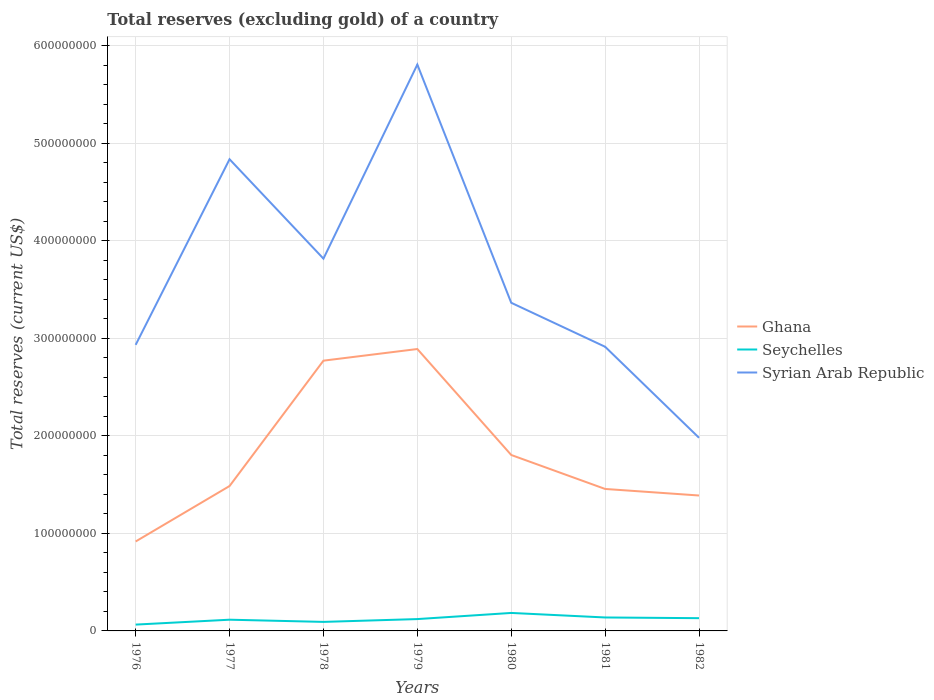Does the line corresponding to Syrian Arab Republic intersect with the line corresponding to Seychelles?
Provide a short and direct response. No. Is the number of lines equal to the number of legend labels?
Ensure brevity in your answer.  Yes. Across all years, what is the maximum total reserves (excluding gold) in Syrian Arab Republic?
Offer a terse response. 1.98e+08. In which year was the total reserves (excluding gold) in Seychelles maximum?
Make the answer very short. 1976. What is the total total reserves (excluding gold) in Ghana in the graph?
Ensure brevity in your answer.  -8.87e+07. What is the difference between the highest and the second highest total reserves (excluding gold) in Syrian Arab Republic?
Your answer should be very brief. 3.83e+08. What is the difference between the highest and the lowest total reserves (excluding gold) in Syrian Arab Republic?
Provide a short and direct response. 3. Is the total reserves (excluding gold) in Syrian Arab Republic strictly greater than the total reserves (excluding gold) in Seychelles over the years?
Provide a succinct answer. No. How many lines are there?
Your answer should be compact. 3. How many years are there in the graph?
Your answer should be very brief. 7. What is the difference between two consecutive major ticks on the Y-axis?
Give a very brief answer. 1.00e+08. Are the values on the major ticks of Y-axis written in scientific E-notation?
Make the answer very short. No. How are the legend labels stacked?
Offer a terse response. Vertical. What is the title of the graph?
Give a very brief answer. Total reserves (excluding gold) of a country. Does "Paraguay" appear as one of the legend labels in the graph?
Ensure brevity in your answer.  No. What is the label or title of the Y-axis?
Make the answer very short. Total reserves (current US$). What is the Total reserves (current US$) in Ghana in 1976?
Ensure brevity in your answer.  9.17e+07. What is the Total reserves (current US$) of Seychelles in 1976?
Your response must be concise. 6.49e+06. What is the Total reserves (current US$) of Syrian Arab Republic in 1976?
Your answer should be compact. 2.93e+08. What is the Total reserves (current US$) of Ghana in 1977?
Keep it short and to the point. 1.49e+08. What is the Total reserves (current US$) of Seychelles in 1977?
Keep it short and to the point. 1.15e+07. What is the Total reserves (current US$) of Syrian Arab Republic in 1977?
Keep it short and to the point. 4.84e+08. What is the Total reserves (current US$) of Ghana in 1978?
Provide a short and direct response. 2.77e+08. What is the Total reserves (current US$) in Seychelles in 1978?
Ensure brevity in your answer.  9.26e+06. What is the Total reserves (current US$) of Syrian Arab Republic in 1978?
Your answer should be very brief. 3.82e+08. What is the Total reserves (current US$) in Ghana in 1979?
Keep it short and to the point. 2.89e+08. What is the Total reserves (current US$) in Seychelles in 1979?
Provide a succinct answer. 1.21e+07. What is the Total reserves (current US$) of Syrian Arab Republic in 1979?
Ensure brevity in your answer.  5.81e+08. What is the Total reserves (current US$) in Ghana in 1980?
Provide a short and direct response. 1.80e+08. What is the Total reserves (current US$) in Seychelles in 1980?
Offer a very short reply. 1.84e+07. What is the Total reserves (current US$) of Syrian Arab Republic in 1980?
Make the answer very short. 3.37e+08. What is the Total reserves (current US$) of Ghana in 1981?
Your answer should be compact. 1.46e+08. What is the Total reserves (current US$) in Seychelles in 1981?
Give a very brief answer. 1.38e+07. What is the Total reserves (current US$) of Syrian Arab Republic in 1981?
Your response must be concise. 2.91e+08. What is the Total reserves (current US$) in Ghana in 1982?
Make the answer very short. 1.39e+08. What is the Total reserves (current US$) of Seychelles in 1982?
Your response must be concise. 1.31e+07. What is the Total reserves (current US$) of Syrian Arab Republic in 1982?
Your answer should be compact. 1.98e+08. Across all years, what is the maximum Total reserves (current US$) of Ghana?
Give a very brief answer. 2.89e+08. Across all years, what is the maximum Total reserves (current US$) in Seychelles?
Make the answer very short. 1.84e+07. Across all years, what is the maximum Total reserves (current US$) of Syrian Arab Republic?
Give a very brief answer. 5.81e+08. Across all years, what is the minimum Total reserves (current US$) in Ghana?
Offer a very short reply. 9.17e+07. Across all years, what is the minimum Total reserves (current US$) of Seychelles?
Keep it short and to the point. 6.49e+06. Across all years, what is the minimum Total reserves (current US$) in Syrian Arab Republic?
Make the answer very short. 1.98e+08. What is the total Total reserves (current US$) of Ghana in the graph?
Offer a terse response. 1.27e+09. What is the total Total reserves (current US$) of Seychelles in the graph?
Offer a very short reply. 8.47e+07. What is the total Total reserves (current US$) of Syrian Arab Republic in the graph?
Give a very brief answer. 2.57e+09. What is the difference between the Total reserves (current US$) of Ghana in 1976 and that in 1977?
Your response must be concise. -5.69e+07. What is the difference between the Total reserves (current US$) of Seychelles in 1976 and that in 1977?
Your answer should be compact. -5.02e+06. What is the difference between the Total reserves (current US$) in Syrian Arab Republic in 1976 and that in 1977?
Keep it short and to the point. -1.90e+08. What is the difference between the Total reserves (current US$) of Ghana in 1976 and that in 1978?
Your answer should be compact. -1.85e+08. What is the difference between the Total reserves (current US$) in Seychelles in 1976 and that in 1978?
Give a very brief answer. -2.77e+06. What is the difference between the Total reserves (current US$) of Syrian Arab Republic in 1976 and that in 1978?
Your answer should be very brief. -8.84e+07. What is the difference between the Total reserves (current US$) of Ghana in 1976 and that in 1979?
Give a very brief answer. -1.97e+08. What is the difference between the Total reserves (current US$) of Seychelles in 1976 and that in 1979?
Your answer should be very brief. -5.66e+06. What is the difference between the Total reserves (current US$) of Syrian Arab Republic in 1976 and that in 1979?
Offer a terse response. -2.87e+08. What is the difference between the Total reserves (current US$) in Ghana in 1976 and that in 1980?
Your answer should be compact. -8.87e+07. What is the difference between the Total reserves (current US$) in Seychelles in 1976 and that in 1980?
Give a very brief answer. -1.19e+07. What is the difference between the Total reserves (current US$) of Syrian Arab Republic in 1976 and that in 1980?
Offer a very short reply. -4.31e+07. What is the difference between the Total reserves (current US$) of Ghana in 1976 and that in 1981?
Provide a short and direct response. -5.39e+07. What is the difference between the Total reserves (current US$) in Seychelles in 1976 and that in 1981?
Your response must be concise. -7.31e+06. What is the difference between the Total reserves (current US$) of Syrian Arab Republic in 1976 and that in 1981?
Provide a succinct answer. 1.97e+06. What is the difference between the Total reserves (current US$) in Ghana in 1976 and that in 1982?
Provide a succinct answer. -4.71e+07. What is the difference between the Total reserves (current US$) of Seychelles in 1976 and that in 1982?
Provide a short and direct response. -6.58e+06. What is the difference between the Total reserves (current US$) of Syrian Arab Republic in 1976 and that in 1982?
Offer a very short reply. 9.53e+07. What is the difference between the Total reserves (current US$) in Ghana in 1977 and that in 1978?
Keep it short and to the point. -1.29e+08. What is the difference between the Total reserves (current US$) in Seychelles in 1977 and that in 1978?
Your answer should be very brief. 2.25e+06. What is the difference between the Total reserves (current US$) in Syrian Arab Republic in 1977 and that in 1978?
Ensure brevity in your answer.  1.02e+08. What is the difference between the Total reserves (current US$) of Ghana in 1977 and that in 1979?
Provide a succinct answer. -1.41e+08. What is the difference between the Total reserves (current US$) of Seychelles in 1977 and that in 1979?
Your answer should be very brief. -6.36e+05. What is the difference between the Total reserves (current US$) in Syrian Arab Republic in 1977 and that in 1979?
Provide a short and direct response. -9.71e+07. What is the difference between the Total reserves (current US$) of Ghana in 1977 and that in 1980?
Ensure brevity in your answer.  -3.18e+07. What is the difference between the Total reserves (current US$) in Seychelles in 1977 and that in 1980?
Give a very brief answer. -6.93e+06. What is the difference between the Total reserves (current US$) in Syrian Arab Republic in 1977 and that in 1980?
Provide a short and direct response. 1.47e+08. What is the difference between the Total reserves (current US$) of Ghana in 1977 and that in 1981?
Your answer should be very brief. 2.99e+06. What is the difference between the Total reserves (current US$) of Seychelles in 1977 and that in 1981?
Offer a very short reply. -2.29e+06. What is the difference between the Total reserves (current US$) in Syrian Arab Republic in 1977 and that in 1981?
Give a very brief answer. 1.92e+08. What is the difference between the Total reserves (current US$) of Ghana in 1977 and that in 1982?
Offer a very short reply. 9.71e+06. What is the difference between the Total reserves (current US$) in Seychelles in 1977 and that in 1982?
Offer a very short reply. -1.56e+06. What is the difference between the Total reserves (current US$) in Syrian Arab Republic in 1977 and that in 1982?
Provide a succinct answer. 2.86e+08. What is the difference between the Total reserves (current US$) in Ghana in 1978 and that in 1979?
Your response must be concise. -1.19e+07. What is the difference between the Total reserves (current US$) in Seychelles in 1978 and that in 1979?
Your answer should be compact. -2.89e+06. What is the difference between the Total reserves (current US$) of Syrian Arab Republic in 1978 and that in 1979?
Provide a short and direct response. -1.99e+08. What is the difference between the Total reserves (current US$) in Ghana in 1978 and that in 1980?
Offer a terse response. 9.67e+07. What is the difference between the Total reserves (current US$) of Seychelles in 1978 and that in 1980?
Offer a terse response. -9.18e+06. What is the difference between the Total reserves (current US$) in Syrian Arab Republic in 1978 and that in 1980?
Your answer should be compact. 4.53e+07. What is the difference between the Total reserves (current US$) of Ghana in 1978 and that in 1981?
Offer a terse response. 1.32e+08. What is the difference between the Total reserves (current US$) in Seychelles in 1978 and that in 1981?
Give a very brief answer. -4.54e+06. What is the difference between the Total reserves (current US$) in Syrian Arab Republic in 1978 and that in 1981?
Offer a terse response. 9.04e+07. What is the difference between the Total reserves (current US$) in Ghana in 1978 and that in 1982?
Your answer should be very brief. 1.38e+08. What is the difference between the Total reserves (current US$) in Seychelles in 1978 and that in 1982?
Your answer should be compact. -3.81e+06. What is the difference between the Total reserves (current US$) in Syrian Arab Republic in 1978 and that in 1982?
Provide a short and direct response. 1.84e+08. What is the difference between the Total reserves (current US$) in Ghana in 1979 and that in 1980?
Offer a very short reply. 1.09e+08. What is the difference between the Total reserves (current US$) of Seychelles in 1979 and that in 1980?
Provide a short and direct response. -6.29e+06. What is the difference between the Total reserves (current US$) in Syrian Arab Republic in 1979 and that in 1980?
Your response must be concise. 2.44e+08. What is the difference between the Total reserves (current US$) of Ghana in 1979 and that in 1981?
Your response must be concise. 1.44e+08. What is the difference between the Total reserves (current US$) of Seychelles in 1979 and that in 1981?
Give a very brief answer. -1.65e+06. What is the difference between the Total reserves (current US$) in Syrian Arab Republic in 1979 and that in 1981?
Your answer should be compact. 2.89e+08. What is the difference between the Total reserves (current US$) of Ghana in 1979 and that in 1982?
Offer a terse response. 1.50e+08. What is the difference between the Total reserves (current US$) of Seychelles in 1979 and that in 1982?
Your answer should be very brief. -9.24e+05. What is the difference between the Total reserves (current US$) of Syrian Arab Republic in 1979 and that in 1982?
Provide a succinct answer. 3.83e+08. What is the difference between the Total reserves (current US$) in Ghana in 1980 and that in 1981?
Give a very brief answer. 3.48e+07. What is the difference between the Total reserves (current US$) of Seychelles in 1980 and that in 1981?
Make the answer very short. 4.64e+06. What is the difference between the Total reserves (current US$) of Syrian Arab Republic in 1980 and that in 1981?
Provide a succinct answer. 4.51e+07. What is the difference between the Total reserves (current US$) in Ghana in 1980 and that in 1982?
Keep it short and to the point. 4.16e+07. What is the difference between the Total reserves (current US$) in Seychelles in 1980 and that in 1982?
Give a very brief answer. 5.37e+06. What is the difference between the Total reserves (current US$) in Syrian Arab Republic in 1980 and that in 1982?
Your answer should be compact. 1.38e+08. What is the difference between the Total reserves (current US$) of Ghana in 1981 and that in 1982?
Offer a terse response. 6.71e+06. What is the difference between the Total reserves (current US$) in Seychelles in 1981 and that in 1982?
Ensure brevity in your answer.  7.28e+05. What is the difference between the Total reserves (current US$) in Syrian Arab Republic in 1981 and that in 1982?
Your answer should be very brief. 9.33e+07. What is the difference between the Total reserves (current US$) in Ghana in 1976 and the Total reserves (current US$) in Seychelles in 1977?
Your response must be concise. 8.02e+07. What is the difference between the Total reserves (current US$) of Ghana in 1976 and the Total reserves (current US$) of Syrian Arab Republic in 1977?
Your answer should be very brief. -3.92e+08. What is the difference between the Total reserves (current US$) of Seychelles in 1976 and the Total reserves (current US$) of Syrian Arab Republic in 1977?
Your answer should be very brief. -4.77e+08. What is the difference between the Total reserves (current US$) of Ghana in 1976 and the Total reserves (current US$) of Seychelles in 1978?
Provide a short and direct response. 8.25e+07. What is the difference between the Total reserves (current US$) of Ghana in 1976 and the Total reserves (current US$) of Syrian Arab Republic in 1978?
Keep it short and to the point. -2.90e+08. What is the difference between the Total reserves (current US$) of Seychelles in 1976 and the Total reserves (current US$) of Syrian Arab Republic in 1978?
Your response must be concise. -3.75e+08. What is the difference between the Total reserves (current US$) of Ghana in 1976 and the Total reserves (current US$) of Seychelles in 1979?
Your answer should be compact. 7.96e+07. What is the difference between the Total reserves (current US$) in Ghana in 1976 and the Total reserves (current US$) in Syrian Arab Republic in 1979?
Keep it short and to the point. -4.89e+08. What is the difference between the Total reserves (current US$) in Seychelles in 1976 and the Total reserves (current US$) in Syrian Arab Republic in 1979?
Provide a succinct answer. -5.74e+08. What is the difference between the Total reserves (current US$) in Ghana in 1976 and the Total reserves (current US$) in Seychelles in 1980?
Your response must be concise. 7.33e+07. What is the difference between the Total reserves (current US$) of Ghana in 1976 and the Total reserves (current US$) of Syrian Arab Republic in 1980?
Your response must be concise. -2.45e+08. What is the difference between the Total reserves (current US$) of Seychelles in 1976 and the Total reserves (current US$) of Syrian Arab Republic in 1980?
Give a very brief answer. -3.30e+08. What is the difference between the Total reserves (current US$) of Ghana in 1976 and the Total reserves (current US$) of Seychelles in 1981?
Your answer should be compact. 7.79e+07. What is the difference between the Total reserves (current US$) in Ghana in 1976 and the Total reserves (current US$) in Syrian Arab Republic in 1981?
Provide a succinct answer. -2.00e+08. What is the difference between the Total reserves (current US$) of Seychelles in 1976 and the Total reserves (current US$) of Syrian Arab Republic in 1981?
Make the answer very short. -2.85e+08. What is the difference between the Total reserves (current US$) in Ghana in 1976 and the Total reserves (current US$) in Seychelles in 1982?
Make the answer very short. 7.87e+07. What is the difference between the Total reserves (current US$) in Ghana in 1976 and the Total reserves (current US$) in Syrian Arab Republic in 1982?
Provide a short and direct response. -1.06e+08. What is the difference between the Total reserves (current US$) of Seychelles in 1976 and the Total reserves (current US$) of Syrian Arab Republic in 1982?
Your answer should be compact. -1.92e+08. What is the difference between the Total reserves (current US$) of Ghana in 1977 and the Total reserves (current US$) of Seychelles in 1978?
Your answer should be very brief. 1.39e+08. What is the difference between the Total reserves (current US$) of Ghana in 1977 and the Total reserves (current US$) of Syrian Arab Republic in 1978?
Give a very brief answer. -2.33e+08. What is the difference between the Total reserves (current US$) of Seychelles in 1977 and the Total reserves (current US$) of Syrian Arab Republic in 1978?
Offer a very short reply. -3.70e+08. What is the difference between the Total reserves (current US$) in Ghana in 1977 and the Total reserves (current US$) in Seychelles in 1979?
Provide a short and direct response. 1.36e+08. What is the difference between the Total reserves (current US$) in Ghana in 1977 and the Total reserves (current US$) in Syrian Arab Republic in 1979?
Your answer should be compact. -4.32e+08. What is the difference between the Total reserves (current US$) in Seychelles in 1977 and the Total reserves (current US$) in Syrian Arab Republic in 1979?
Keep it short and to the point. -5.69e+08. What is the difference between the Total reserves (current US$) of Ghana in 1977 and the Total reserves (current US$) of Seychelles in 1980?
Your answer should be very brief. 1.30e+08. What is the difference between the Total reserves (current US$) in Ghana in 1977 and the Total reserves (current US$) in Syrian Arab Republic in 1980?
Keep it short and to the point. -1.88e+08. What is the difference between the Total reserves (current US$) in Seychelles in 1977 and the Total reserves (current US$) in Syrian Arab Republic in 1980?
Give a very brief answer. -3.25e+08. What is the difference between the Total reserves (current US$) of Ghana in 1977 and the Total reserves (current US$) of Seychelles in 1981?
Offer a terse response. 1.35e+08. What is the difference between the Total reserves (current US$) in Ghana in 1977 and the Total reserves (current US$) in Syrian Arab Republic in 1981?
Keep it short and to the point. -1.43e+08. What is the difference between the Total reserves (current US$) in Seychelles in 1977 and the Total reserves (current US$) in Syrian Arab Republic in 1981?
Give a very brief answer. -2.80e+08. What is the difference between the Total reserves (current US$) in Ghana in 1977 and the Total reserves (current US$) in Seychelles in 1982?
Your answer should be very brief. 1.36e+08. What is the difference between the Total reserves (current US$) in Ghana in 1977 and the Total reserves (current US$) in Syrian Arab Republic in 1982?
Provide a succinct answer. -4.95e+07. What is the difference between the Total reserves (current US$) in Seychelles in 1977 and the Total reserves (current US$) in Syrian Arab Republic in 1982?
Make the answer very short. -1.87e+08. What is the difference between the Total reserves (current US$) of Ghana in 1978 and the Total reserves (current US$) of Seychelles in 1979?
Keep it short and to the point. 2.65e+08. What is the difference between the Total reserves (current US$) of Ghana in 1978 and the Total reserves (current US$) of Syrian Arab Republic in 1979?
Provide a short and direct response. -3.04e+08. What is the difference between the Total reserves (current US$) of Seychelles in 1978 and the Total reserves (current US$) of Syrian Arab Republic in 1979?
Provide a succinct answer. -5.72e+08. What is the difference between the Total reserves (current US$) in Ghana in 1978 and the Total reserves (current US$) in Seychelles in 1980?
Your response must be concise. 2.59e+08. What is the difference between the Total reserves (current US$) in Ghana in 1978 and the Total reserves (current US$) in Syrian Arab Republic in 1980?
Make the answer very short. -5.94e+07. What is the difference between the Total reserves (current US$) in Seychelles in 1978 and the Total reserves (current US$) in Syrian Arab Republic in 1980?
Your response must be concise. -3.27e+08. What is the difference between the Total reserves (current US$) in Ghana in 1978 and the Total reserves (current US$) in Seychelles in 1981?
Keep it short and to the point. 2.63e+08. What is the difference between the Total reserves (current US$) of Ghana in 1978 and the Total reserves (current US$) of Syrian Arab Republic in 1981?
Your answer should be compact. -1.43e+07. What is the difference between the Total reserves (current US$) in Seychelles in 1978 and the Total reserves (current US$) in Syrian Arab Republic in 1981?
Keep it short and to the point. -2.82e+08. What is the difference between the Total reserves (current US$) in Ghana in 1978 and the Total reserves (current US$) in Seychelles in 1982?
Your answer should be very brief. 2.64e+08. What is the difference between the Total reserves (current US$) in Ghana in 1978 and the Total reserves (current US$) in Syrian Arab Republic in 1982?
Make the answer very short. 7.91e+07. What is the difference between the Total reserves (current US$) in Seychelles in 1978 and the Total reserves (current US$) in Syrian Arab Republic in 1982?
Keep it short and to the point. -1.89e+08. What is the difference between the Total reserves (current US$) in Ghana in 1979 and the Total reserves (current US$) in Seychelles in 1980?
Make the answer very short. 2.71e+08. What is the difference between the Total reserves (current US$) of Ghana in 1979 and the Total reserves (current US$) of Syrian Arab Republic in 1980?
Offer a very short reply. -4.74e+07. What is the difference between the Total reserves (current US$) in Seychelles in 1979 and the Total reserves (current US$) in Syrian Arab Republic in 1980?
Your answer should be compact. -3.24e+08. What is the difference between the Total reserves (current US$) in Ghana in 1979 and the Total reserves (current US$) in Seychelles in 1981?
Give a very brief answer. 2.75e+08. What is the difference between the Total reserves (current US$) in Ghana in 1979 and the Total reserves (current US$) in Syrian Arab Republic in 1981?
Give a very brief answer. -2.31e+06. What is the difference between the Total reserves (current US$) of Seychelles in 1979 and the Total reserves (current US$) of Syrian Arab Republic in 1981?
Your answer should be very brief. -2.79e+08. What is the difference between the Total reserves (current US$) of Ghana in 1979 and the Total reserves (current US$) of Seychelles in 1982?
Offer a terse response. 2.76e+08. What is the difference between the Total reserves (current US$) in Ghana in 1979 and the Total reserves (current US$) in Syrian Arab Republic in 1982?
Keep it short and to the point. 9.10e+07. What is the difference between the Total reserves (current US$) of Seychelles in 1979 and the Total reserves (current US$) of Syrian Arab Republic in 1982?
Provide a short and direct response. -1.86e+08. What is the difference between the Total reserves (current US$) in Ghana in 1980 and the Total reserves (current US$) in Seychelles in 1981?
Your response must be concise. 1.67e+08. What is the difference between the Total reserves (current US$) of Ghana in 1980 and the Total reserves (current US$) of Syrian Arab Republic in 1981?
Your response must be concise. -1.11e+08. What is the difference between the Total reserves (current US$) of Seychelles in 1980 and the Total reserves (current US$) of Syrian Arab Republic in 1981?
Offer a very short reply. -2.73e+08. What is the difference between the Total reserves (current US$) in Ghana in 1980 and the Total reserves (current US$) in Seychelles in 1982?
Your answer should be very brief. 1.67e+08. What is the difference between the Total reserves (current US$) of Ghana in 1980 and the Total reserves (current US$) of Syrian Arab Republic in 1982?
Make the answer very short. -1.76e+07. What is the difference between the Total reserves (current US$) in Seychelles in 1980 and the Total reserves (current US$) in Syrian Arab Republic in 1982?
Offer a terse response. -1.80e+08. What is the difference between the Total reserves (current US$) of Ghana in 1981 and the Total reserves (current US$) of Seychelles in 1982?
Your answer should be compact. 1.33e+08. What is the difference between the Total reserves (current US$) in Ghana in 1981 and the Total reserves (current US$) in Syrian Arab Republic in 1982?
Your response must be concise. -5.25e+07. What is the difference between the Total reserves (current US$) of Seychelles in 1981 and the Total reserves (current US$) of Syrian Arab Republic in 1982?
Ensure brevity in your answer.  -1.84e+08. What is the average Total reserves (current US$) of Ghana per year?
Offer a terse response. 1.82e+08. What is the average Total reserves (current US$) of Seychelles per year?
Make the answer very short. 1.21e+07. What is the average Total reserves (current US$) of Syrian Arab Republic per year?
Your answer should be compact. 3.67e+08. In the year 1976, what is the difference between the Total reserves (current US$) of Ghana and Total reserves (current US$) of Seychelles?
Offer a very short reply. 8.52e+07. In the year 1976, what is the difference between the Total reserves (current US$) in Ghana and Total reserves (current US$) in Syrian Arab Republic?
Make the answer very short. -2.02e+08. In the year 1976, what is the difference between the Total reserves (current US$) of Seychelles and Total reserves (current US$) of Syrian Arab Republic?
Your answer should be compact. -2.87e+08. In the year 1977, what is the difference between the Total reserves (current US$) of Ghana and Total reserves (current US$) of Seychelles?
Make the answer very short. 1.37e+08. In the year 1977, what is the difference between the Total reserves (current US$) in Ghana and Total reserves (current US$) in Syrian Arab Republic?
Your answer should be very brief. -3.35e+08. In the year 1977, what is the difference between the Total reserves (current US$) of Seychelles and Total reserves (current US$) of Syrian Arab Republic?
Give a very brief answer. -4.72e+08. In the year 1978, what is the difference between the Total reserves (current US$) in Ghana and Total reserves (current US$) in Seychelles?
Your answer should be very brief. 2.68e+08. In the year 1978, what is the difference between the Total reserves (current US$) of Ghana and Total reserves (current US$) of Syrian Arab Republic?
Give a very brief answer. -1.05e+08. In the year 1978, what is the difference between the Total reserves (current US$) in Seychelles and Total reserves (current US$) in Syrian Arab Republic?
Provide a short and direct response. -3.73e+08. In the year 1979, what is the difference between the Total reserves (current US$) of Ghana and Total reserves (current US$) of Seychelles?
Give a very brief answer. 2.77e+08. In the year 1979, what is the difference between the Total reserves (current US$) of Ghana and Total reserves (current US$) of Syrian Arab Republic?
Offer a terse response. -2.92e+08. In the year 1979, what is the difference between the Total reserves (current US$) of Seychelles and Total reserves (current US$) of Syrian Arab Republic?
Make the answer very short. -5.69e+08. In the year 1980, what is the difference between the Total reserves (current US$) in Ghana and Total reserves (current US$) in Seychelles?
Offer a very short reply. 1.62e+08. In the year 1980, what is the difference between the Total reserves (current US$) in Ghana and Total reserves (current US$) in Syrian Arab Republic?
Provide a succinct answer. -1.56e+08. In the year 1980, what is the difference between the Total reserves (current US$) of Seychelles and Total reserves (current US$) of Syrian Arab Republic?
Provide a short and direct response. -3.18e+08. In the year 1981, what is the difference between the Total reserves (current US$) in Ghana and Total reserves (current US$) in Seychelles?
Provide a short and direct response. 1.32e+08. In the year 1981, what is the difference between the Total reserves (current US$) in Ghana and Total reserves (current US$) in Syrian Arab Republic?
Provide a succinct answer. -1.46e+08. In the year 1981, what is the difference between the Total reserves (current US$) of Seychelles and Total reserves (current US$) of Syrian Arab Republic?
Provide a succinct answer. -2.78e+08. In the year 1982, what is the difference between the Total reserves (current US$) of Ghana and Total reserves (current US$) of Seychelles?
Your answer should be compact. 1.26e+08. In the year 1982, what is the difference between the Total reserves (current US$) in Ghana and Total reserves (current US$) in Syrian Arab Republic?
Provide a short and direct response. -5.92e+07. In the year 1982, what is the difference between the Total reserves (current US$) of Seychelles and Total reserves (current US$) of Syrian Arab Republic?
Ensure brevity in your answer.  -1.85e+08. What is the ratio of the Total reserves (current US$) of Ghana in 1976 to that in 1977?
Provide a short and direct response. 0.62. What is the ratio of the Total reserves (current US$) of Seychelles in 1976 to that in 1977?
Offer a very short reply. 0.56. What is the ratio of the Total reserves (current US$) of Syrian Arab Republic in 1976 to that in 1977?
Provide a succinct answer. 0.61. What is the ratio of the Total reserves (current US$) in Ghana in 1976 to that in 1978?
Give a very brief answer. 0.33. What is the ratio of the Total reserves (current US$) in Seychelles in 1976 to that in 1978?
Keep it short and to the point. 0.7. What is the ratio of the Total reserves (current US$) in Syrian Arab Republic in 1976 to that in 1978?
Ensure brevity in your answer.  0.77. What is the ratio of the Total reserves (current US$) of Ghana in 1976 to that in 1979?
Your answer should be compact. 0.32. What is the ratio of the Total reserves (current US$) of Seychelles in 1976 to that in 1979?
Give a very brief answer. 0.53. What is the ratio of the Total reserves (current US$) of Syrian Arab Republic in 1976 to that in 1979?
Offer a terse response. 0.51. What is the ratio of the Total reserves (current US$) of Ghana in 1976 to that in 1980?
Your answer should be very brief. 0.51. What is the ratio of the Total reserves (current US$) of Seychelles in 1976 to that in 1980?
Ensure brevity in your answer.  0.35. What is the ratio of the Total reserves (current US$) of Syrian Arab Republic in 1976 to that in 1980?
Ensure brevity in your answer.  0.87. What is the ratio of the Total reserves (current US$) of Ghana in 1976 to that in 1981?
Ensure brevity in your answer.  0.63. What is the ratio of the Total reserves (current US$) in Seychelles in 1976 to that in 1981?
Offer a terse response. 0.47. What is the ratio of the Total reserves (current US$) in Syrian Arab Republic in 1976 to that in 1981?
Provide a succinct answer. 1.01. What is the ratio of the Total reserves (current US$) in Ghana in 1976 to that in 1982?
Provide a succinct answer. 0.66. What is the ratio of the Total reserves (current US$) of Seychelles in 1976 to that in 1982?
Your response must be concise. 0.5. What is the ratio of the Total reserves (current US$) in Syrian Arab Republic in 1976 to that in 1982?
Provide a short and direct response. 1.48. What is the ratio of the Total reserves (current US$) in Ghana in 1977 to that in 1978?
Your answer should be compact. 0.54. What is the ratio of the Total reserves (current US$) of Seychelles in 1977 to that in 1978?
Your response must be concise. 1.24. What is the ratio of the Total reserves (current US$) of Syrian Arab Republic in 1977 to that in 1978?
Provide a succinct answer. 1.27. What is the ratio of the Total reserves (current US$) of Ghana in 1977 to that in 1979?
Offer a terse response. 0.51. What is the ratio of the Total reserves (current US$) of Seychelles in 1977 to that in 1979?
Offer a very short reply. 0.95. What is the ratio of the Total reserves (current US$) of Syrian Arab Republic in 1977 to that in 1979?
Ensure brevity in your answer.  0.83. What is the ratio of the Total reserves (current US$) of Ghana in 1977 to that in 1980?
Give a very brief answer. 0.82. What is the ratio of the Total reserves (current US$) in Seychelles in 1977 to that in 1980?
Your answer should be very brief. 0.62. What is the ratio of the Total reserves (current US$) in Syrian Arab Republic in 1977 to that in 1980?
Offer a terse response. 1.44. What is the ratio of the Total reserves (current US$) in Ghana in 1977 to that in 1981?
Make the answer very short. 1.02. What is the ratio of the Total reserves (current US$) in Seychelles in 1977 to that in 1981?
Your answer should be compact. 0.83. What is the ratio of the Total reserves (current US$) of Syrian Arab Republic in 1977 to that in 1981?
Make the answer very short. 1.66. What is the ratio of the Total reserves (current US$) in Ghana in 1977 to that in 1982?
Your answer should be very brief. 1.07. What is the ratio of the Total reserves (current US$) in Seychelles in 1977 to that in 1982?
Offer a very short reply. 0.88. What is the ratio of the Total reserves (current US$) in Syrian Arab Republic in 1977 to that in 1982?
Provide a succinct answer. 2.44. What is the ratio of the Total reserves (current US$) in Ghana in 1978 to that in 1979?
Offer a very short reply. 0.96. What is the ratio of the Total reserves (current US$) of Seychelles in 1978 to that in 1979?
Give a very brief answer. 0.76. What is the ratio of the Total reserves (current US$) in Syrian Arab Republic in 1978 to that in 1979?
Keep it short and to the point. 0.66. What is the ratio of the Total reserves (current US$) of Ghana in 1978 to that in 1980?
Keep it short and to the point. 1.54. What is the ratio of the Total reserves (current US$) of Seychelles in 1978 to that in 1980?
Offer a very short reply. 0.5. What is the ratio of the Total reserves (current US$) in Syrian Arab Republic in 1978 to that in 1980?
Your answer should be compact. 1.13. What is the ratio of the Total reserves (current US$) of Ghana in 1978 to that in 1981?
Your answer should be compact. 1.9. What is the ratio of the Total reserves (current US$) in Seychelles in 1978 to that in 1981?
Offer a very short reply. 0.67. What is the ratio of the Total reserves (current US$) of Syrian Arab Republic in 1978 to that in 1981?
Offer a terse response. 1.31. What is the ratio of the Total reserves (current US$) in Ghana in 1978 to that in 1982?
Give a very brief answer. 2. What is the ratio of the Total reserves (current US$) of Seychelles in 1978 to that in 1982?
Offer a very short reply. 0.71. What is the ratio of the Total reserves (current US$) of Syrian Arab Republic in 1978 to that in 1982?
Offer a very short reply. 1.93. What is the ratio of the Total reserves (current US$) in Ghana in 1979 to that in 1980?
Provide a short and direct response. 1.6. What is the ratio of the Total reserves (current US$) in Seychelles in 1979 to that in 1980?
Offer a very short reply. 0.66. What is the ratio of the Total reserves (current US$) of Syrian Arab Republic in 1979 to that in 1980?
Offer a terse response. 1.73. What is the ratio of the Total reserves (current US$) of Ghana in 1979 to that in 1981?
Your answer should be very brief. 1.99. What is the ratio of the Total reserves (current US$) in Seychelles in 1979 to that in 1981?
Your answer should be compact. 0.88. What is the ratio of the Total reserves (current US$) in Syrian Arab Republic in 1979 to that in 1981?
Provide a succinct answer. 1.99. What is the ratio of the Total reserves (current US$) of Ghana in 1979 to that in 1982?
Your answer should be very brief. 2.08. What is the ratio of the Total reserves (current US$) in Seychelles in 1979 to that in 1982?
Provide a short and direct response. 0.93. What is the ratio of the Total reserves (current US$) of Syrian Arab Republic in 1979 to that in 1982?
Your answer should be compact. 2.93. What is the ratio of the Total reserves (current US$) of Ghana in 1980 to that in 1981?
Make the answer very short. 1.24. What is the ratio of the Total reserves (current US$) in Seychelles in 1980 to that in 1981?
Ensure brevity in your answer.  1.34. What is the ratio of the Total reserves (current US$) of Syrian Arab Republic in 1980 to that in 1981?
Keep it short and to the point. 1.15. What is the ratio of the Total reserves (current US$) of Ghana in 1980 to that in 1982?
Provide a short and direct response. 1.3. What is the ratio of the Total reserves (current US$) in Seychelles in 1980 to that in 1982?
Make the answer very short. 1.41. What is the ratio of the Total reserves (current US$) of Syrian Arab Republic in 1980 to that in 1982?
Offer a terse response. 1.7. What is the ratio of the Total reserves (current US$) of Ghana in 1981 to that in 1982?
Your answer should be very brief. 1.05. What is the ratio of the Total reserves (current US$) in Seychelles in 1981 to that in 1982?
Make the answer very short. 1.06. What is the ratio of the Total reserves (current US$) of Syrian Arab Republic in 1981 to that in 1982?
Provide a short and direct response. 1.47. What is the difference between the highest and the second highest Total reserves (current US$) in Ghana?
Offer a very short reply. 1.19e+07. What is the difference between the highest and the second highest Total reserves (current US$) in Seychelles?
Give a very brief answer. 4.64e+06. What is the difference between the highest and the second highest Total reserves (current US$) in Syrian Arab Republic?
Give a very brief answer. 9.71e+07. What is the difference between the highest and the lowest Total reserves (current US$) of Ghana?
Provide a succinct answer. 1.97e+08. What is the difference between the highest and the lowest Total reserves (current US$) of Seychelles?
Your response must be concise. 1.19e+07. What is the difference between the highest and the lowest Total reserves (current US$) of Syrian Arab Republic?
Provide a short and direct response. 3.83e+08. 